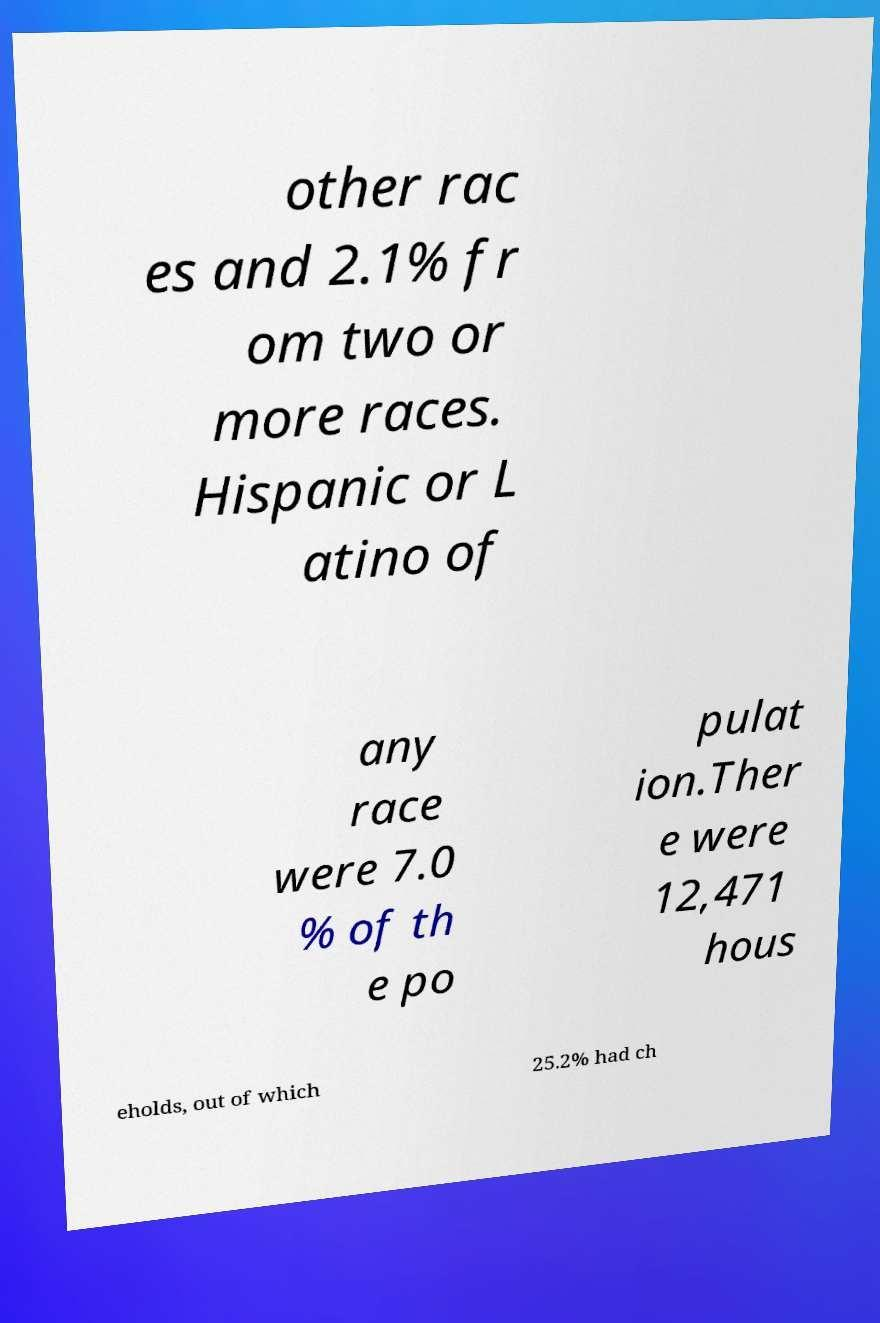I need the written content from this picture converted into text. Can you do that? other rac es and 2.1% fr om two or more races. Hispanic or L atino of any race were 7.0 % of th e po pulat ion.Ther e were 12,471 hous eholds, out of which 25.2% had ch 